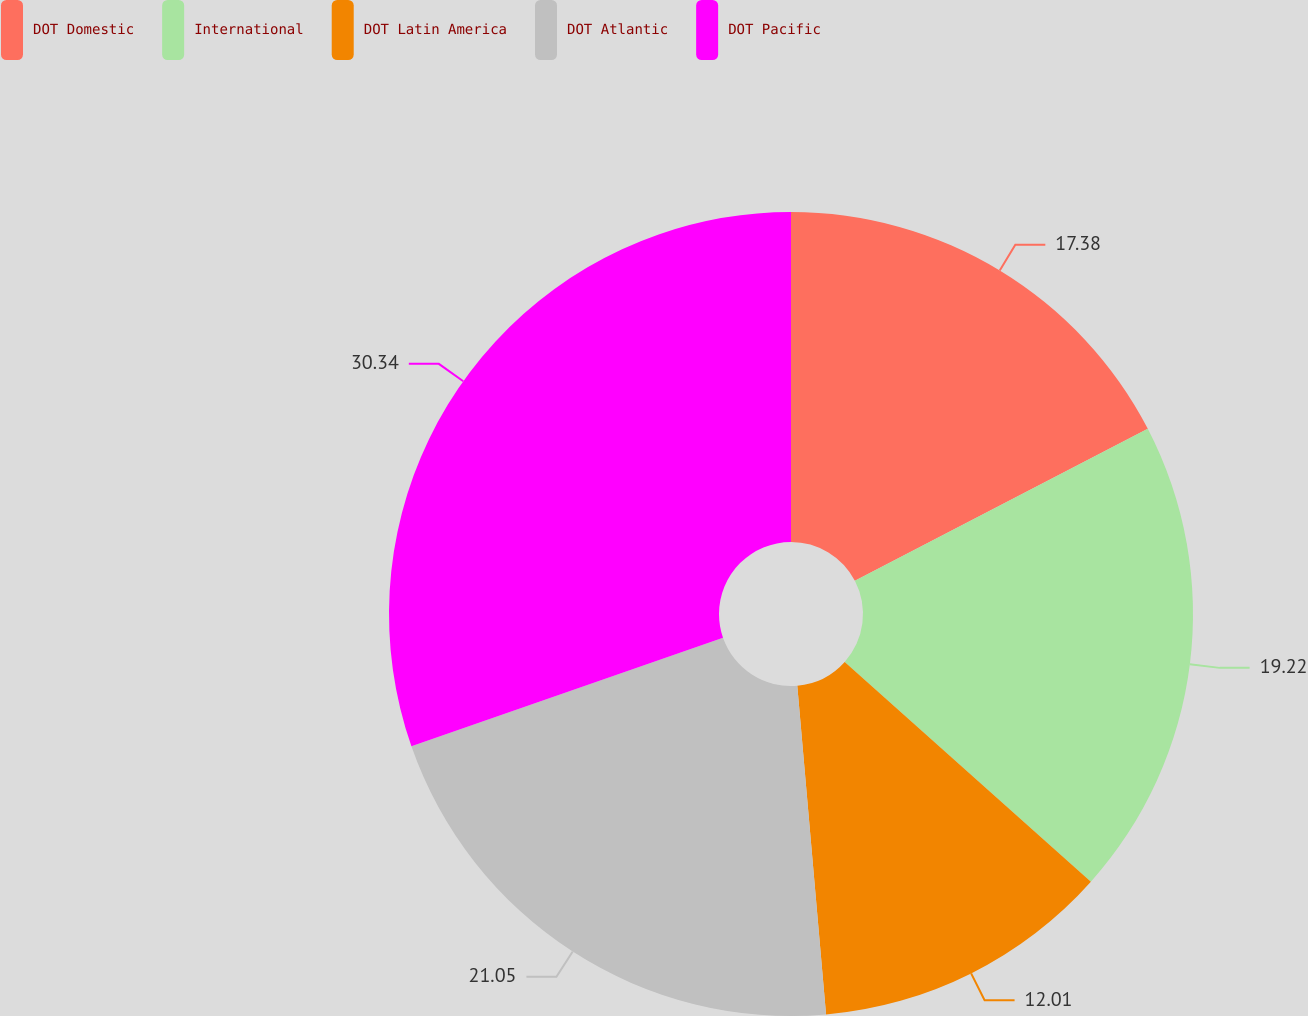Convert chart. <chart><loc_0><loc_0><loc_500><loc_500><pie_chart><fcel>DOT Domestic<fcel>International<fcel>DOT Latin America<fcel>DOT Atlantic<fcel>DOT Pacific<nl><fcel>17.38%<fcel>19.22%<fcel>12.01%<fcel>21.05%<fcel>30.34%<nl></chart> 